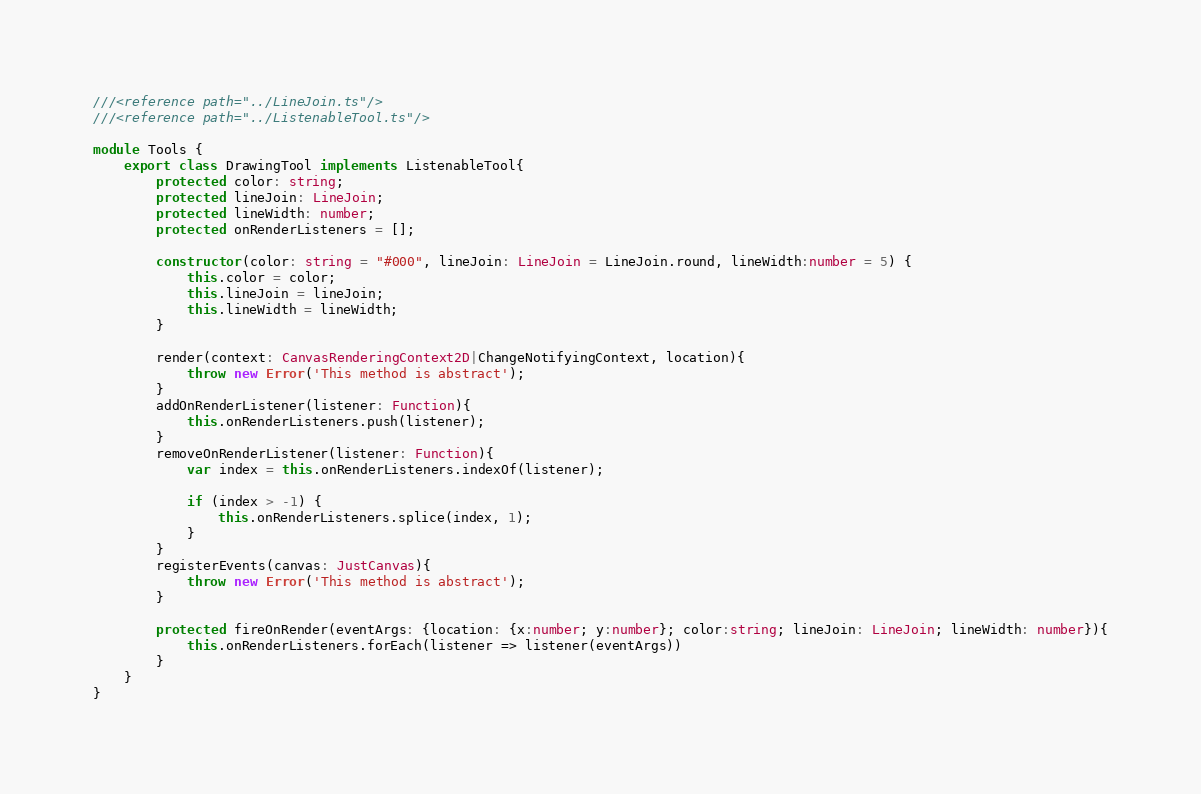Convert code to text. <code><loc_0><loc_0><loc_500><loc_500><_TypeScript_>///<reference path="../LineJoin.ts"/>
///<reference path="../ListenableTool.ts"/>

module Tools {
    export class DrawingTool implements ListenableTool{
        protected color: string;
        protected lineJoin: LineJoin;
        protected lineWidth: number;
        protected onRenderListeners = [];

        constructor(color: string = "#000", lineJoin: LineJoin = LineJoin.round, lineWidth:number = 5) {
            this.color = color;
            this.lineJoin = lineJoin;
            this.lineWidth = lineWidth;
        }

        render(context: CanvasRenderingContext2D|ChangeNotifyingContext, location){
            throw new Error('This method is abstract');
        }
        addOnRenderListener(listener: Function){
            this.onRenderListeners.push(listener);
        }
        removeOnRenderListener(listener: Function){
            var index = this.onRenderListeners.indexOf(listener);

            if (index > -1) {
                this.onRenderListeners.splice(index, 1);
            }
        }
        registerEvents(canvas: JustCanvas){
            throw new Error('This method is abstract');
        }

        protected fireOnRender(eventArgs: {location: {x:number; y:number}; color:string; lineJoin: LineJoin; lineWidth: number}){
            this.onRenderListeners.forEach(listener => listener(eventArgs))
        }
    }
}</code> 